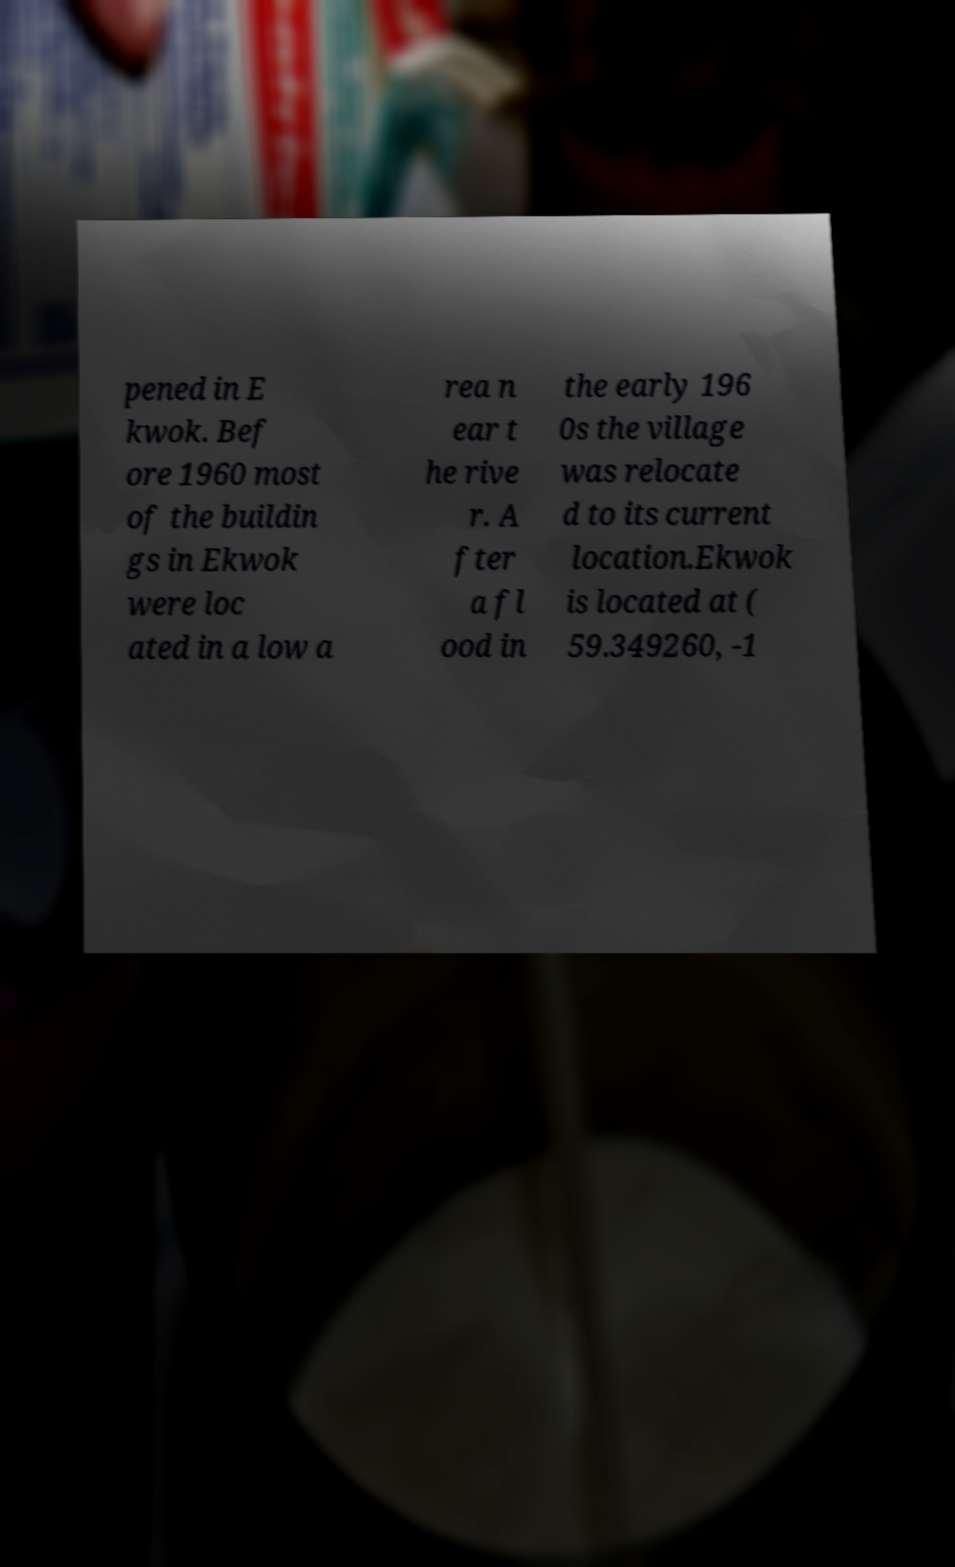There's text embedded in this image that I need extracted. Can you transcribe it verbatim? pened in E kwok. Bef ore 1960 most of the buildin gs in Ekwok were loc ated in a low a rea n ear t he rive r. A fter a fl ood in the early 196 0s the village was relocate d to its current location.Ekwok is located at ( 59.349260, -1 